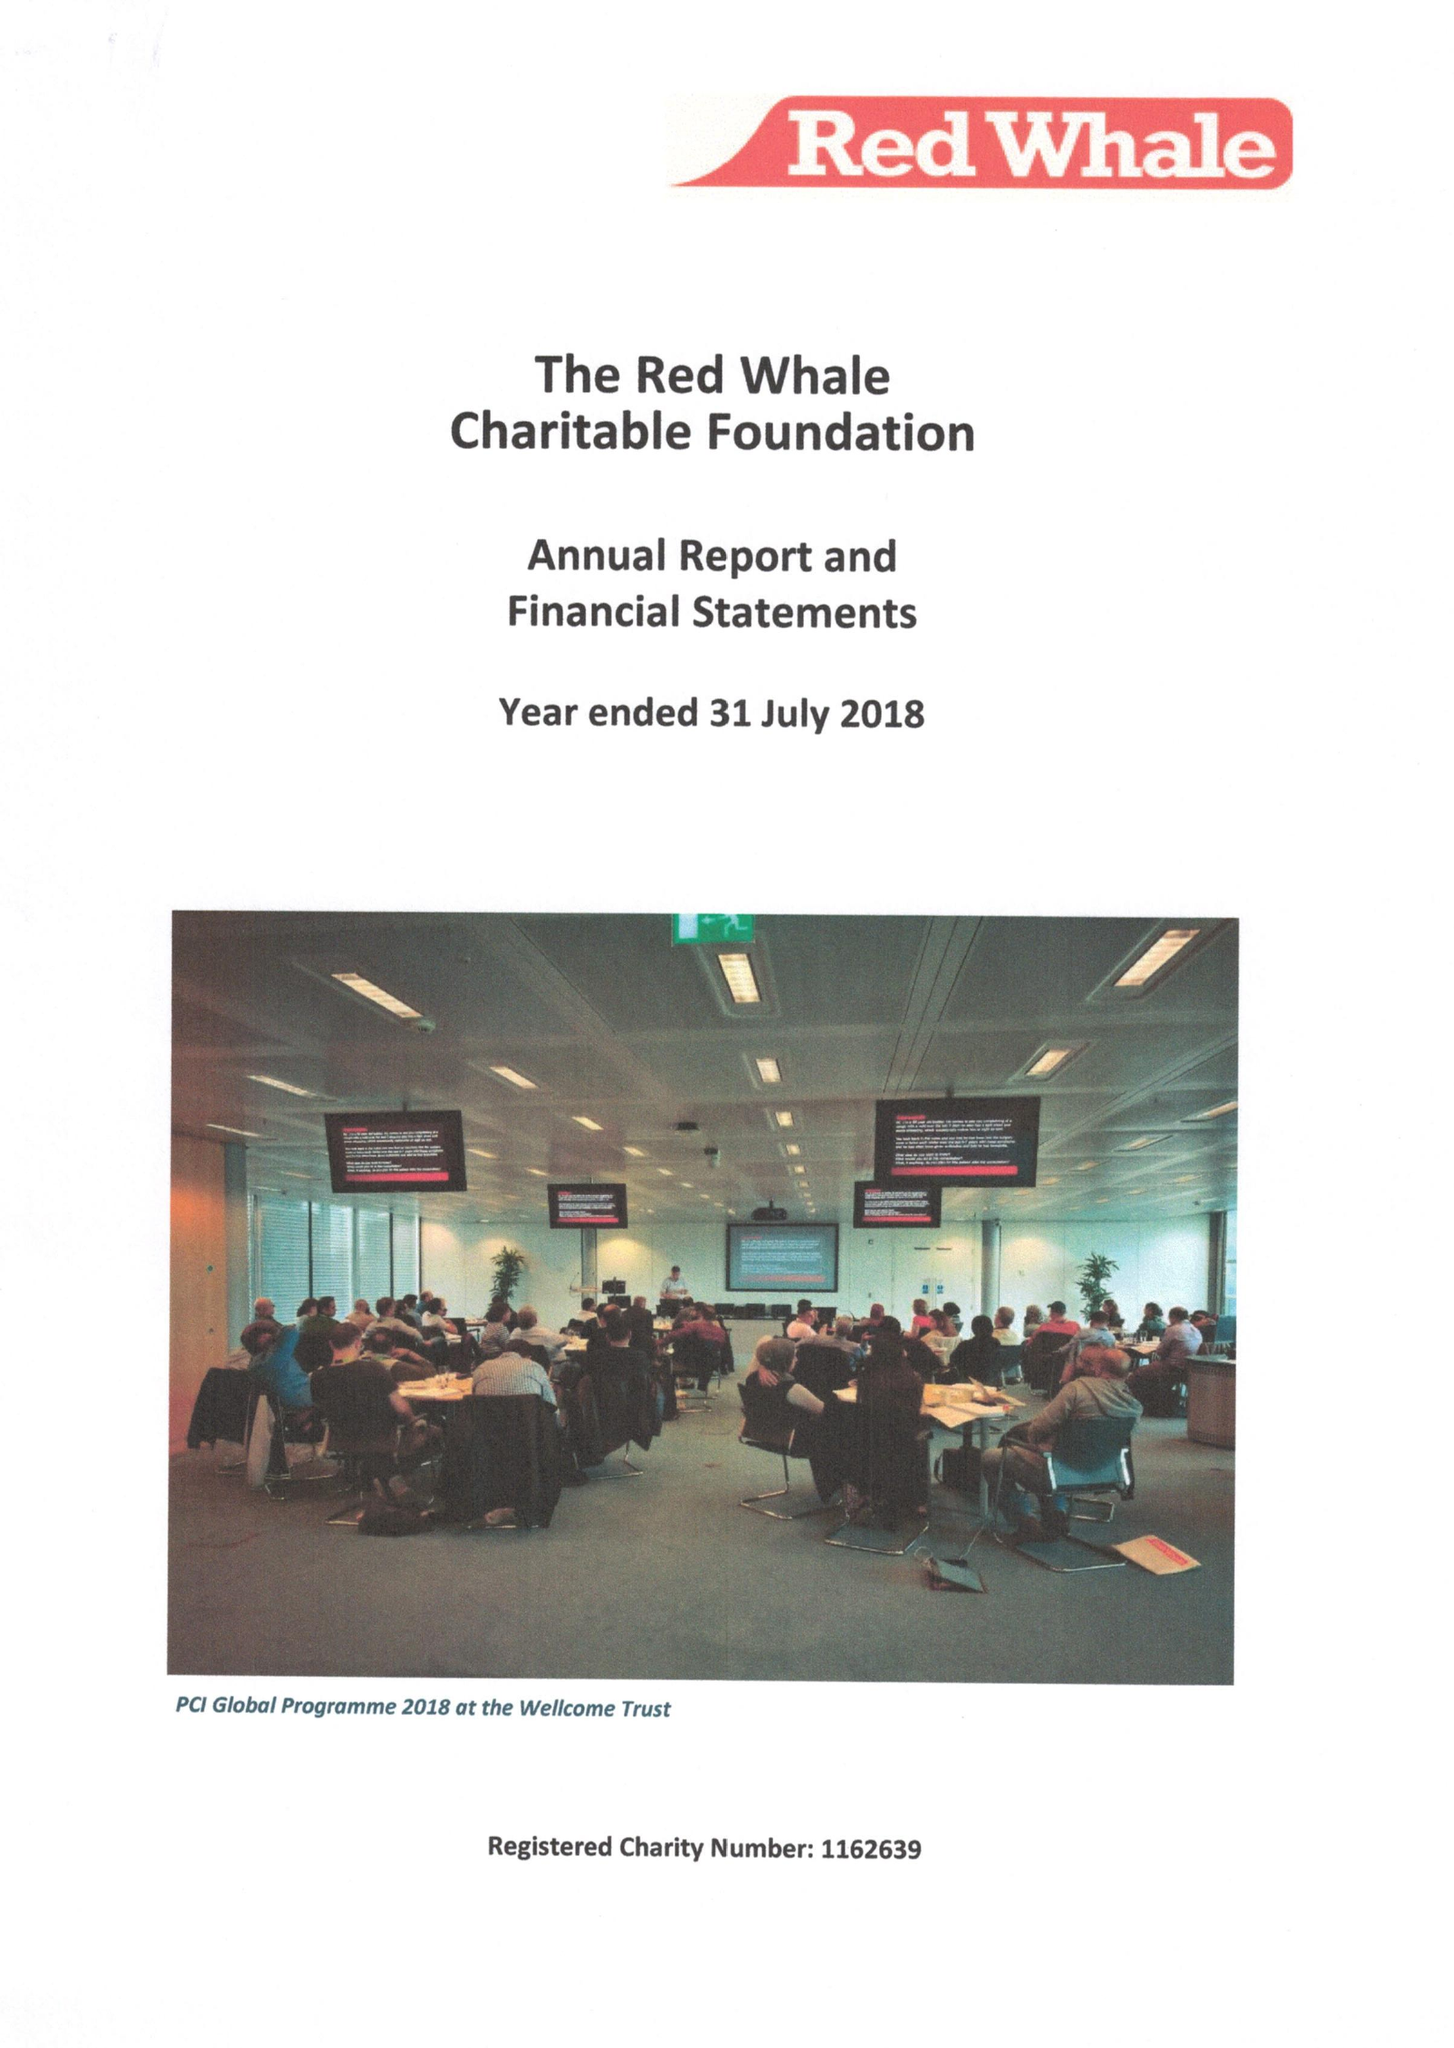What is the value for the charity_number?
Answer the question using a single word or phrase. 1162639 